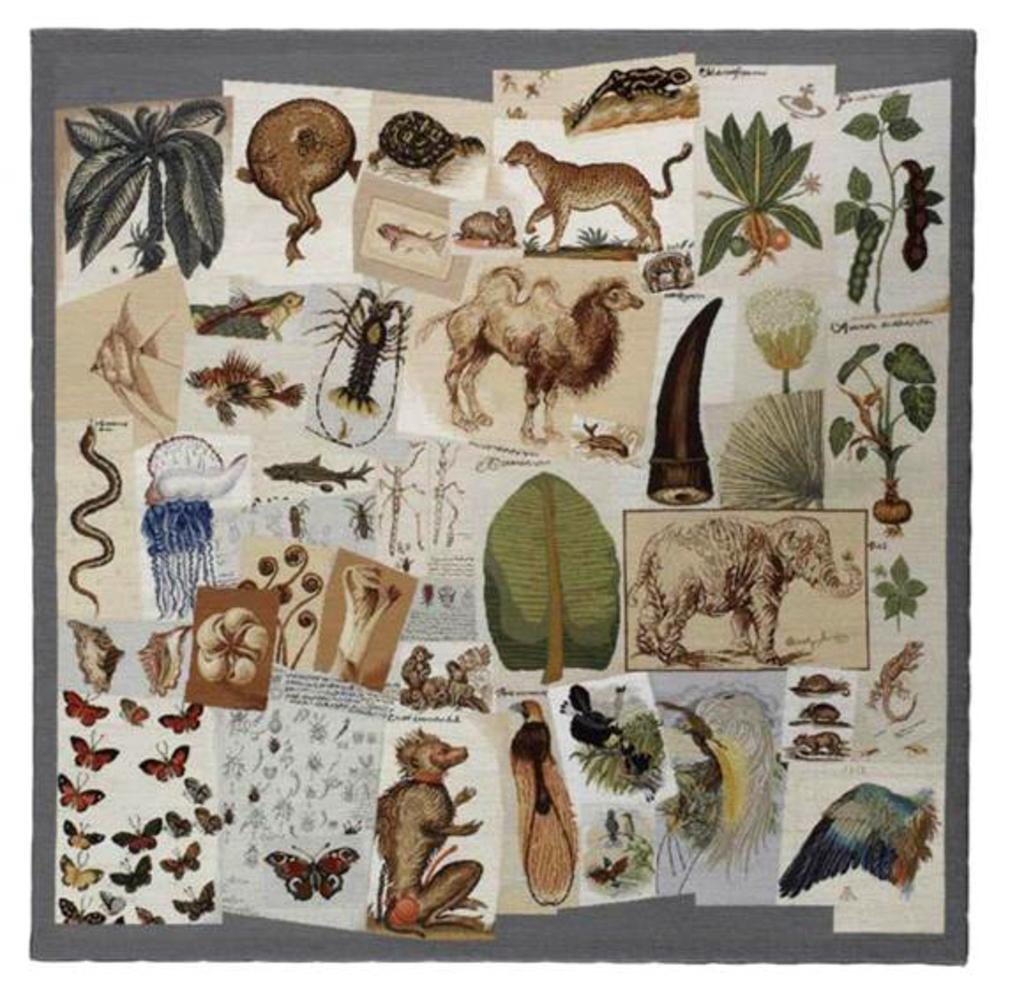What types of living organisms are depicted in the images? The images contain pictures of animals, birds, insects, and butterflies. What other types of images can be seen in the image? The image contains pictures of trees and plants. How many different types of living organisms are depicted in the images? There are four types of living organisms depicted: animals, birds, insects, and butterflies. What reward does the dad receive for completing the task in the image? There is no task or dad present in the image; it contains pictures of animals, birds, insects, trees, plants, and butterflies. 